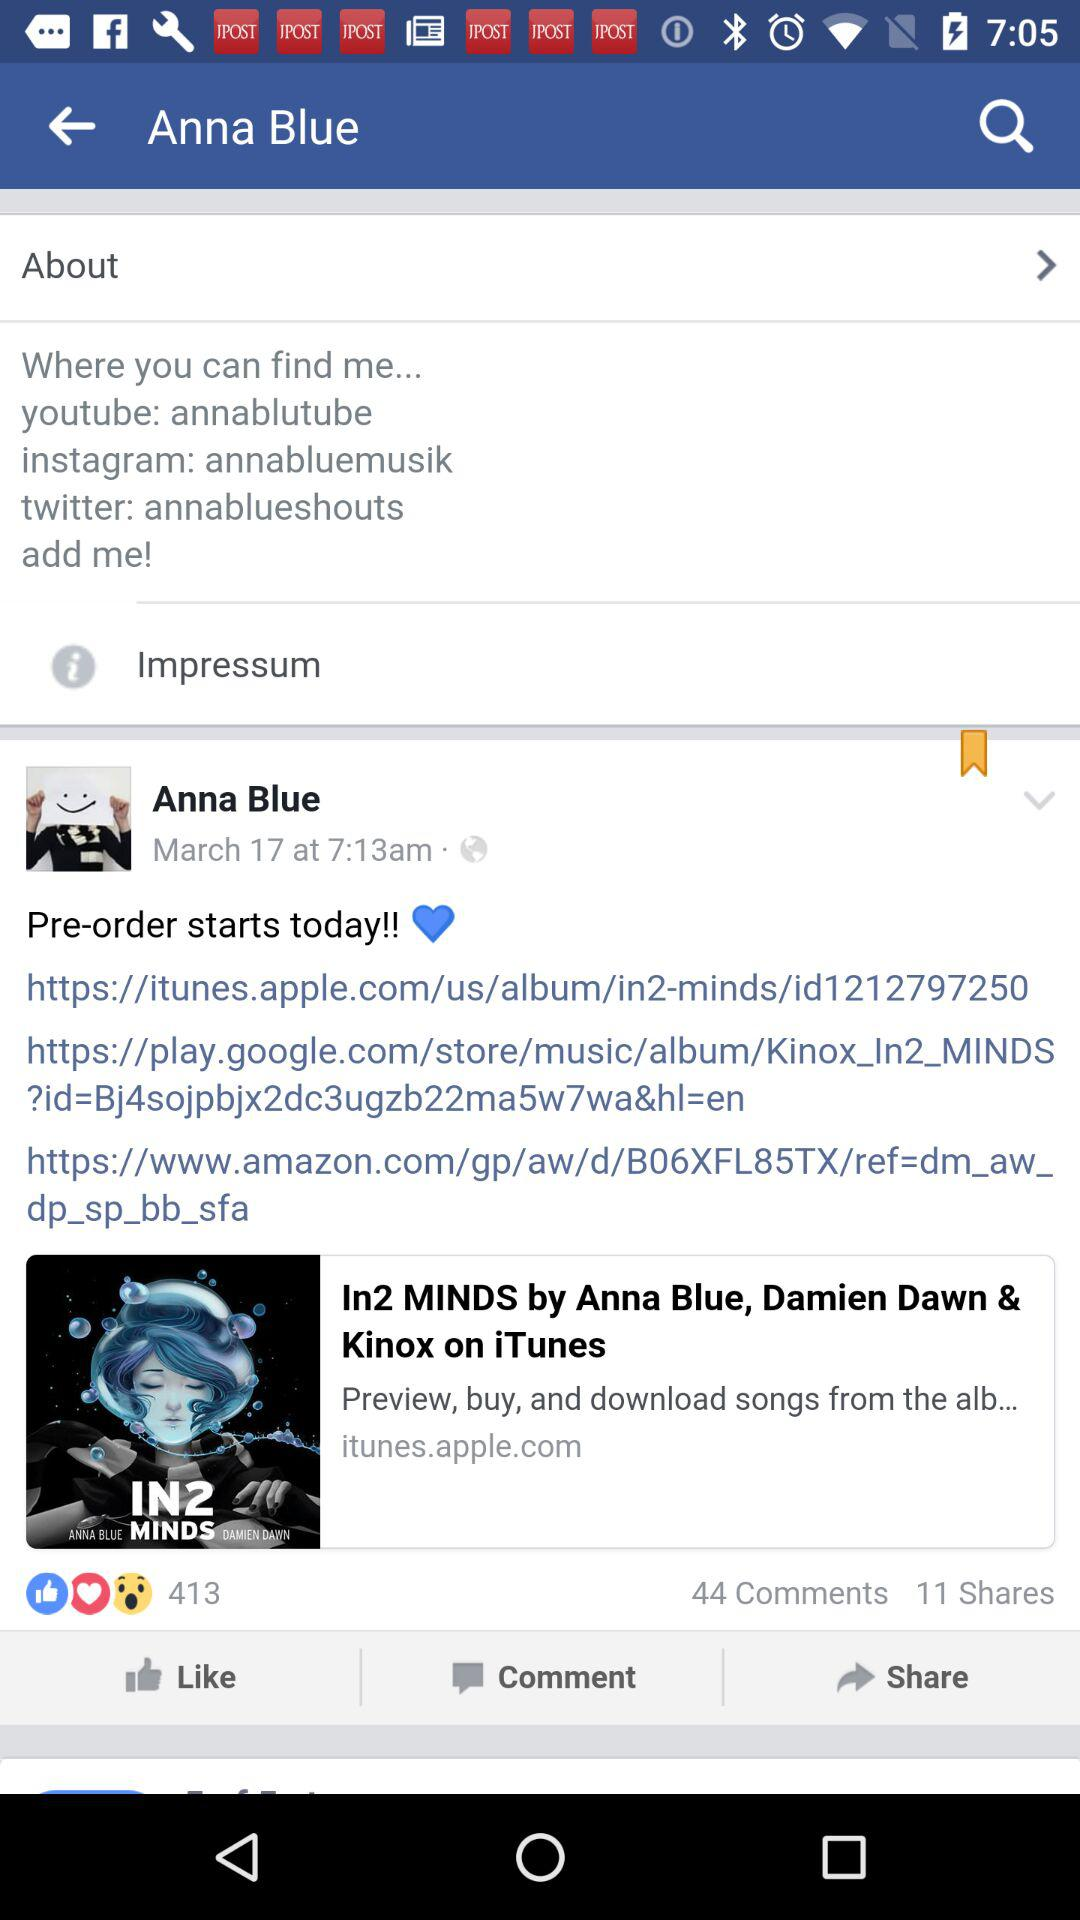How many more comments than shares are there?
Answer the question using a single word or phrase. 33 